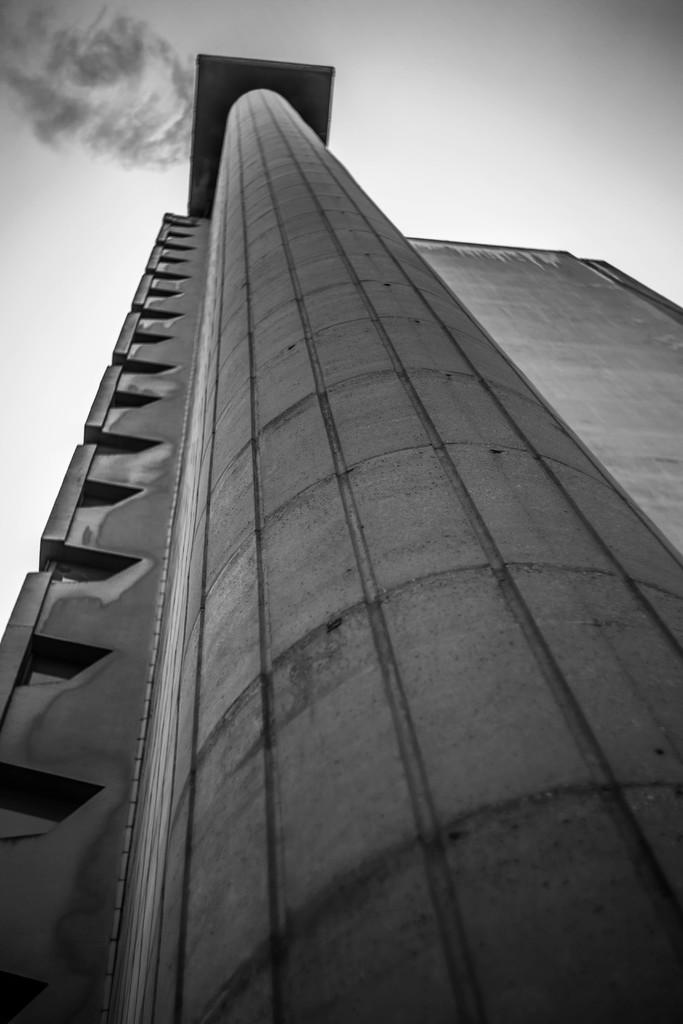What is the color scheme of the picture? The picture is in black and white. From what perspective was the picture taken? The picture is taken from a low angle. What type of structure can be seen in the picture? There is a building in the picture. What is visible at the top of the picture? The sky is visible at the top of the picture. What type of weather can be seen in the picture? There is no indication of weather in the black and white picture. Is there a club visible in the image? There is no mention of a club in the provided facts, and therefore it cannot be determined if one is present in the image. 